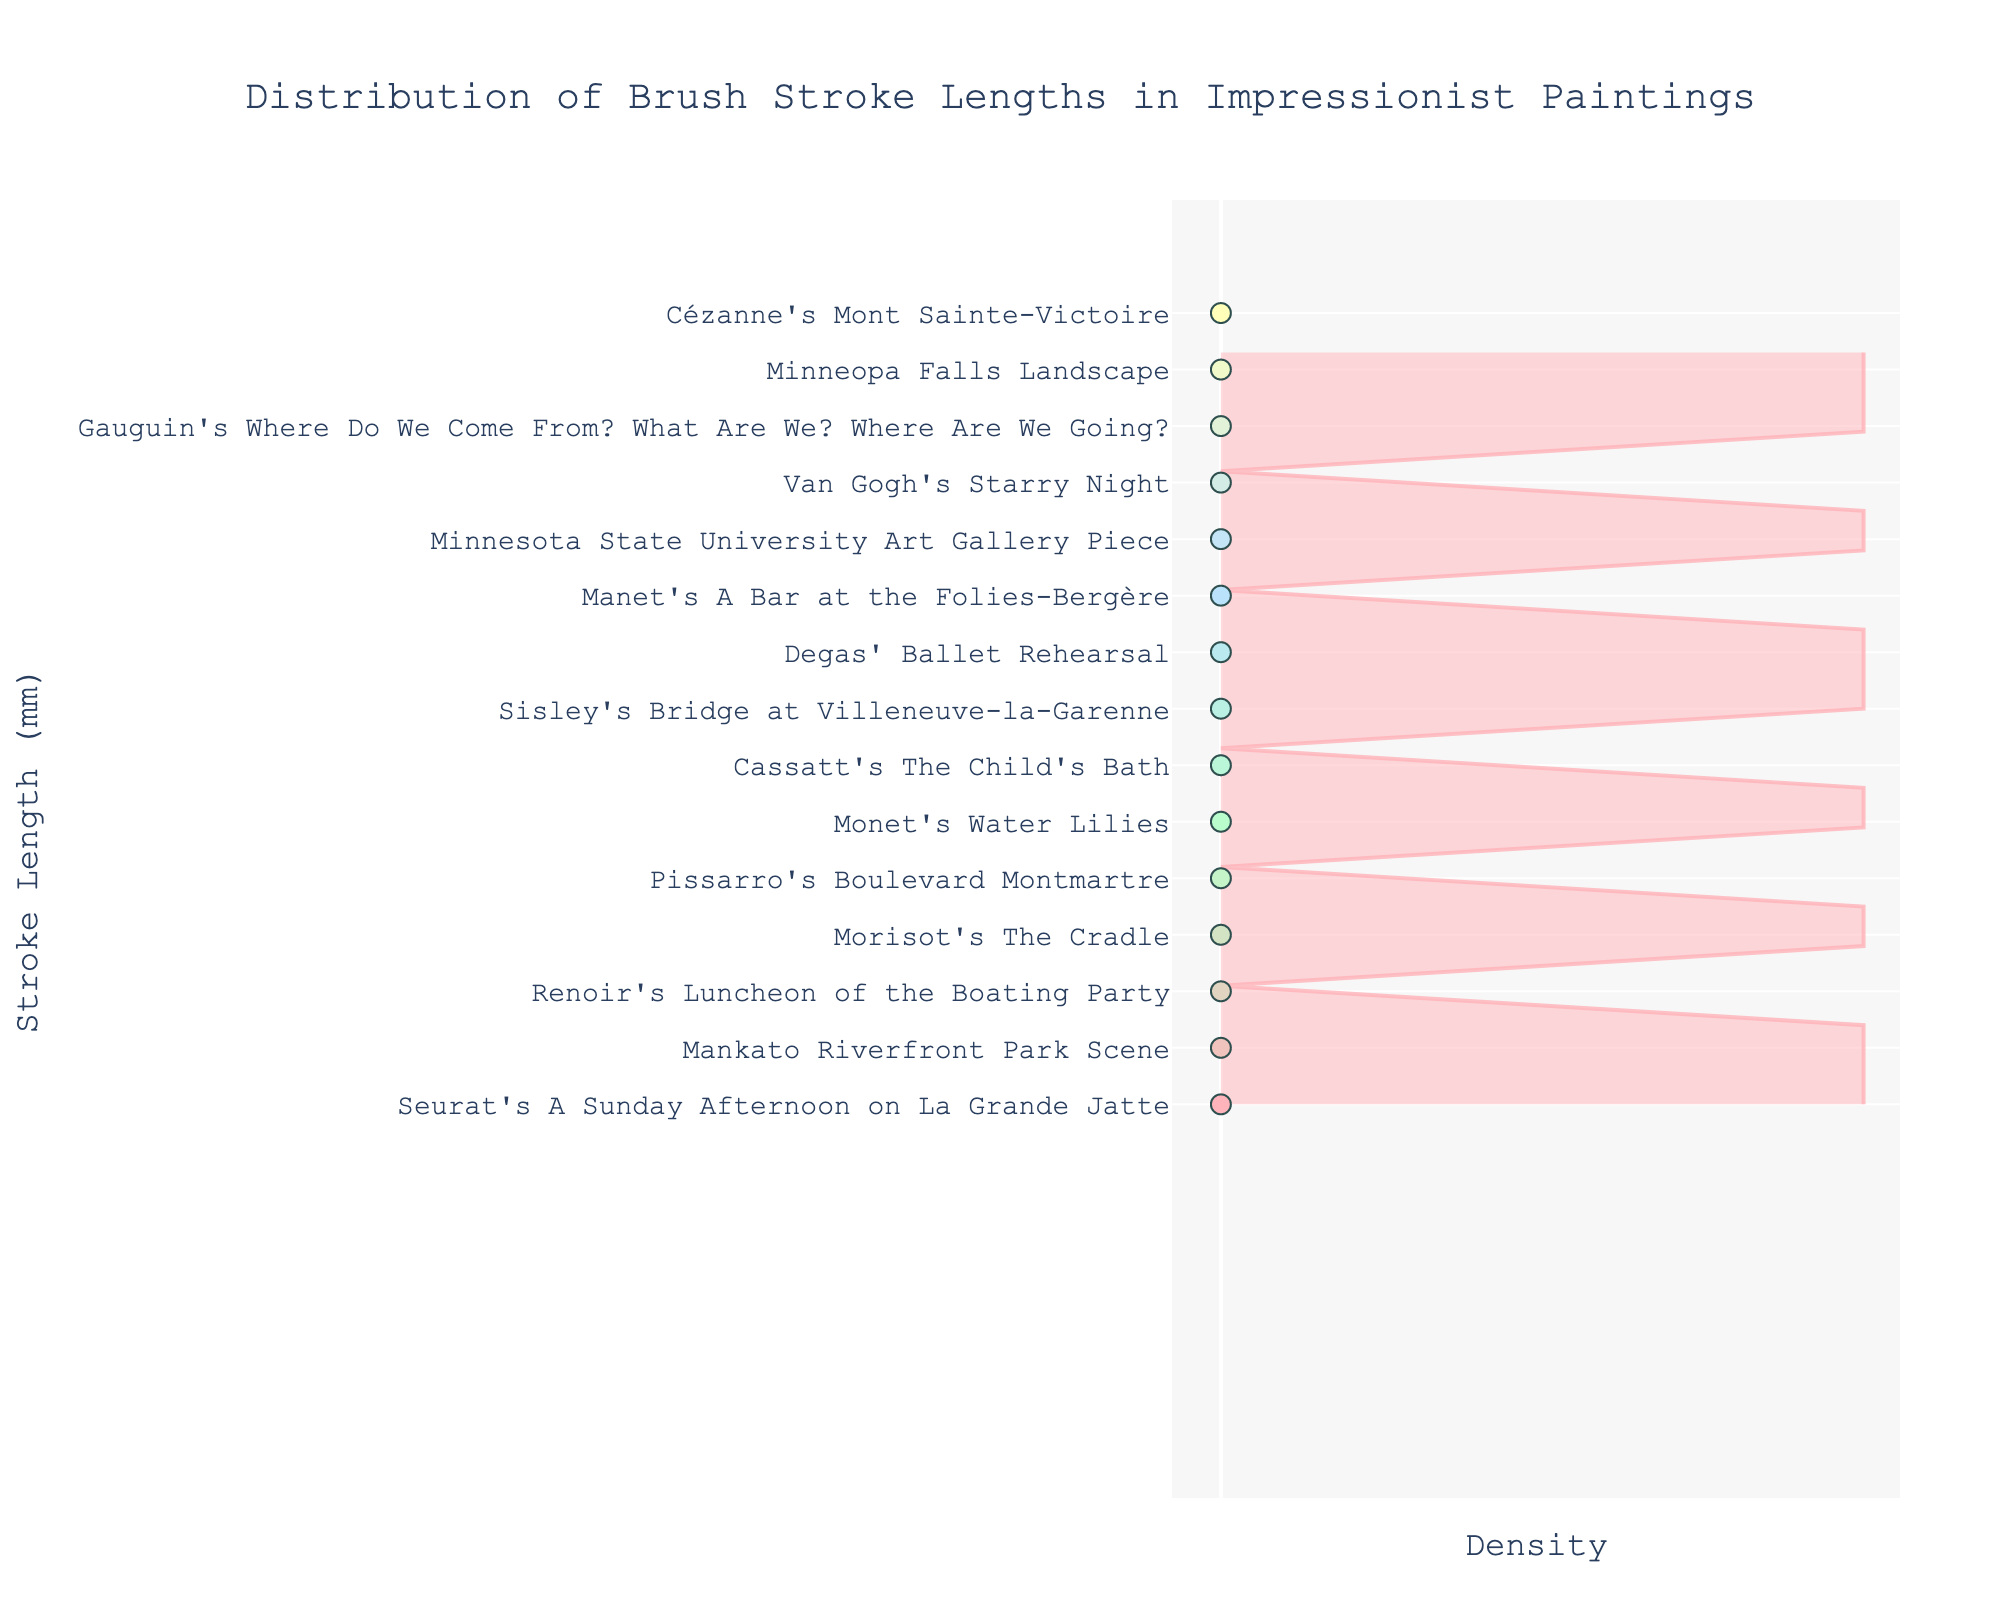What's the title of the figure? The title is located at the top center of the figure, indicating what the plot is about. It reads "Distribution of Brush Stroke Lengths in Impressionist Paintings".
Answer: Distribution of Brush Stroke Lengths in Impressionist Paintings What does the y-axis represent? The y-axis represents the brush stroke lengths in millimeters, as indicated by the label "Stroke Length (mm)".
Answer: Stroke Length (mm) How many different paintings are represented in the figure? To determine the number of different paintings, we count the number of data points or labels along the y-axis. There are 15 different painting names listed.
Answer: 15 Which painting has the longest brush stroke length? By examining the y-axis labels and their positions, Cézanne's Mont Sainte-Victoire is the highest on the y-axis, indicating it has the longest brush stroke length.
Answer: Cézanne's Mont Sainte-Victoire What is the brush stroke length of Van Gogh's Starry Night? Locate Van Gogh's Starry Night along the y-axis, next to the y-tick that represents its brush stroke length. The corresponding stroke length is 18 mm.
Answer: 18 mm Which painting has a brush stroke length of 10 mm? Identify the y-tick for 10 mm and see which painting is listed next to it. Morisot's The Cradle is listed at the 10 mm mark.
Answer: Morisot's The Cradle What is the range of brush stroke lengths in the figure? The minimum and maximum y-tick values indicate the range; here the minimum stroke length is 7 mm (Seurat's painting) and the maximum is 21 mm (Cézanne's painting).
Answer: 7 mm to 21 mm How many paintings have brush stroke lengths shorter than 12 mm? Count the y-ticks that have lengths less than 12 mm and the corresponding paintings. There are four such paintings: Renoir's Luncheon of the Boating Party, Seurat's A Sunday Afternoon on La Grande Jatte, Morisot's The Cradle, and Mankato Riverfront Park Scene.
Answer: 4 What is the median brush stroke length of the paintings? To find the median, list all the stroke lengths in ascending order: 7, 8, 9, 10, 11, 12, 13, 14, 15, 16, 17, 18, 19, 20, 21. The middle value in this ordered list is 14 mm (Sisley's Bridge at Villeneuve-la-Garenne).
Answer: 14 mm Which two paintings have a brush stroke length closest to 10 mm and 20 mm, respectively? For 10 mm, the painting is Morisot's The Cradle. For 20 mm, it is Minneopa Falls Landscape.
Answer: Morisot's The Cradle (10 mm) and Minneopa Falls Landscape (20 mm) What can be inferred about Seurat's brush stroke lengths compared to Monet's? Comparing the y-ticks for Seurat's A Sunday Afternoon on La Grande Jatte (7 mm) and Monet's Water Lilies (12 mm), Seurat's strokes are shorter.
Answer: Seurat's strokes are shorter 